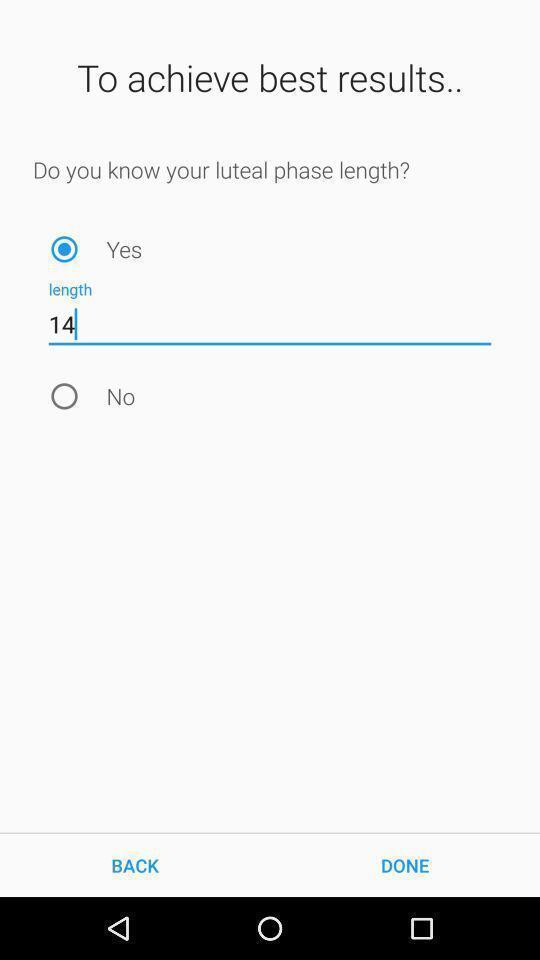Provide a description of this screenshot. Screen showing to achieve best results. 